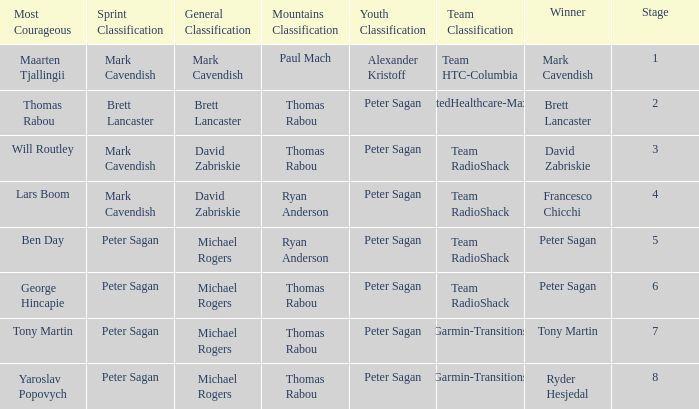When Brett Lancaster won the general classification, who won the team calssification? UnitedHealthcare-Maxxis. 